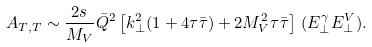Convert formula to latex. <formula><loc_0><loc_0><loc_500><loc_500>A _ { T , T } \sim \frac { 2 s \, } { M _ { V } } \bar { Q } ^ { 2 } \left [ k _ { \perp } ^ { 2 } ( 1 + 4 \tau \bar { \tau } ) + 2 M _ { V } ^ { 2 } \tau \bar { \tau } \right ] \, ( E ^ { \gamma } _ { \perp } E ^ { V } _ { \perp } ) .</formula> 